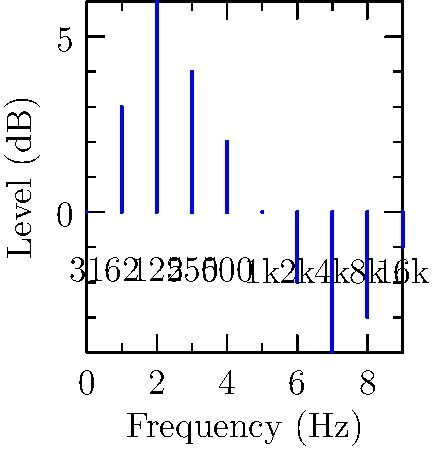As a DJ, you notice that the crowd's energy is dropping during a watch party. Looking at the graphic equalizer interface above, which frequency range should you boost to add more "thump" to the music and reinvigorate the audience? To answer this question, we need to consider the following steps:

1. Understand the frequency spectrum:
   - Low frequencies (20-250 Hz): Bass, "thump"
   - Mid-range frequencies (250-4000 Hz): Vocals, most instruments
   - High frequencies (4000-20000 Hz): Cymbals, high-hats, brilliance

2. Identify the target frequency range:
   - "Thump" is associated with low frequencies, typically around 60-125 Hz

3. Analyze the graphic equalizer:
   - The x-axis shows frequencies from 31 Hz to 16 kHz
   - The y-axis shows the level adjustment in decibels (dB)

4. Locate the relevant frequency band:
   - The 62 Hz and 125 Hz bands are in the ideal range for adding "thump"

5. Choose the most effective option:
   - The 62 Hz band is already boosted by 3 dB
   - The 125 Hz band is boosted the most at 6 dB

6. Make a decision:
   - Boosting the 125 Hz band further would add the most "thump" to the music

Therefore, to add more "thump" and reinvigorate the audience, you should focus on boosting the 125 Hz frequency range.
Answer: 125 Hz 